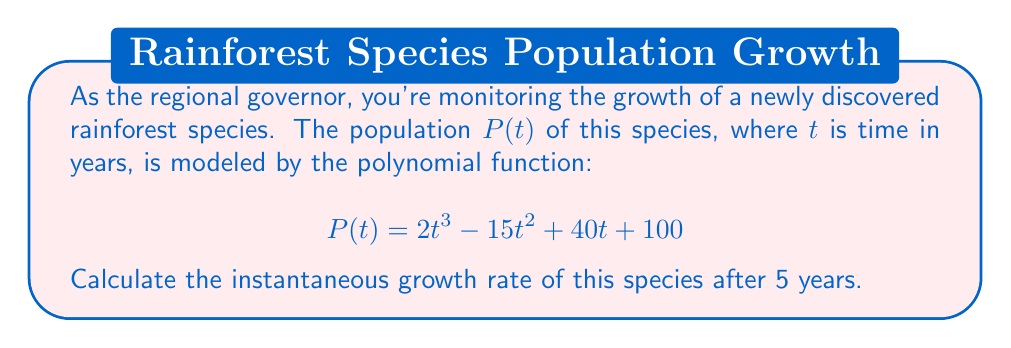Give your solution to this math problem. To find the instantaneous growth rate after 5 years, we need to calculate the derivative of the population function $P(t)$ and evaluate it at $t=5$. Here's how we do it:

1) First, let's find the derivative of $P(t)$:
   $$P(t) = 2t^3 - 15t^2 + 40t + 100$$
   $$P'(t) = 6t^2 - 30t + 40$$

   This derivative represents the rate of change of the population at any given time $t$.

2) Now, we need to evaluate $P'(t)$ at $t=5$:
   $$P'(5) = 6(5)^2 - 30(5) + 40$$
   $$= 6(25) - 150 + 40$$
   $$= 150 - 150 + 40$$
   $$= 40$$

3) Therefore, the instantaneous growth rate after 5 years is 40 individuals per year.

This positive value indicates that the population is increasing at this point in time, which is crucial information for sustainable development and eco-tourism planning in the rainforest.
Answer: 40 individuals/year 